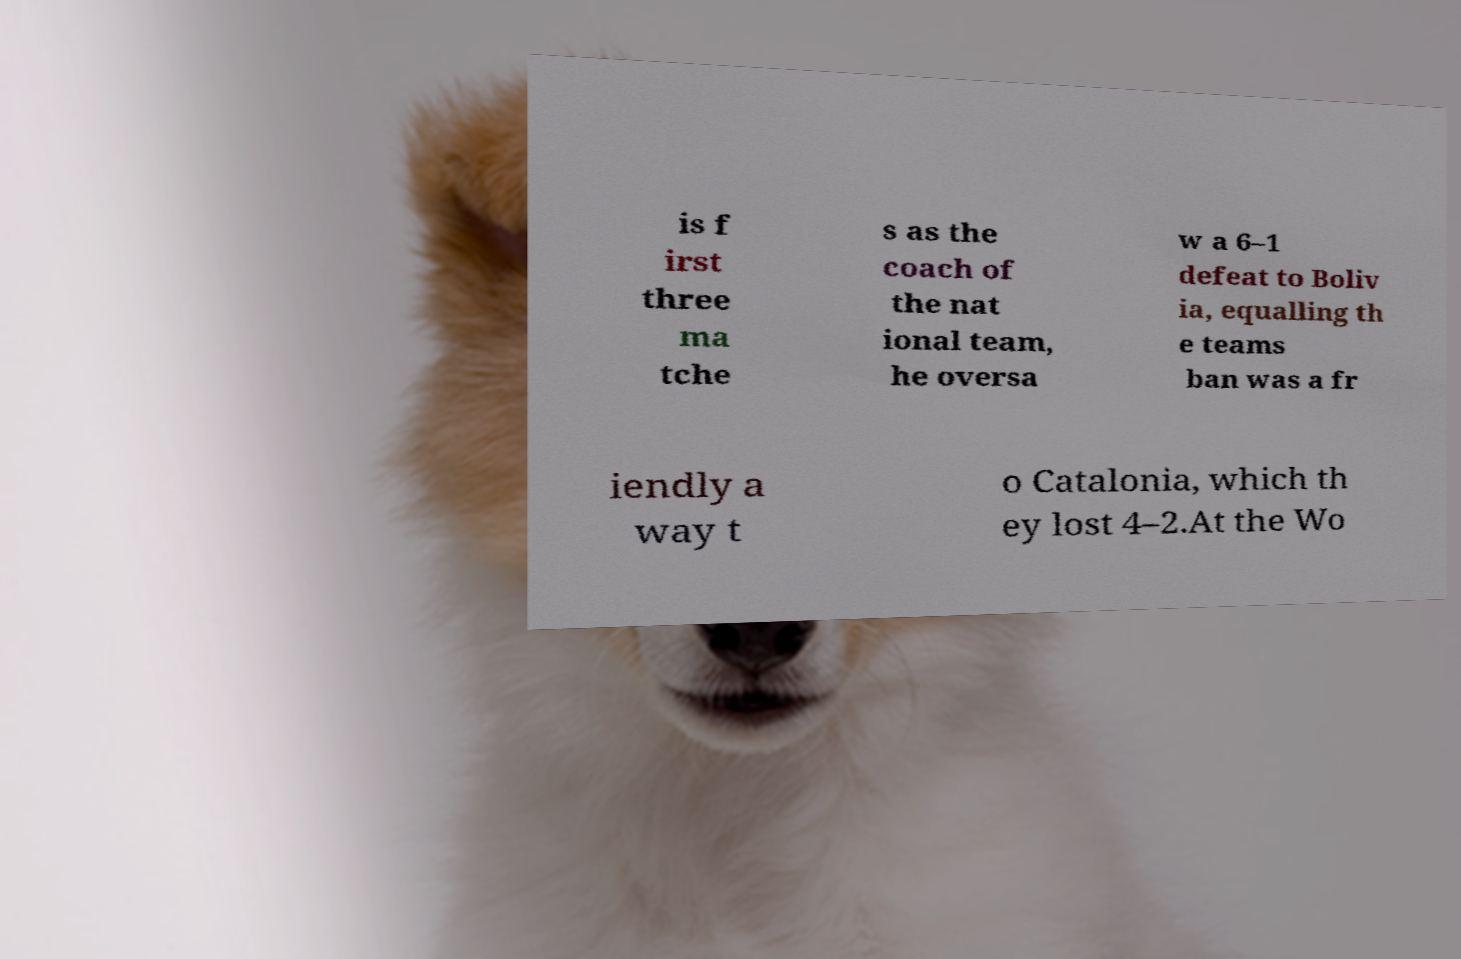I need the written content from this picture converted into text. Can you do that? is f irst three ma tche s as the coach of the nat ional team, he oversa w a 6–1 defeat to Boliv ia, equalling th e teams ban was a fr iendly a way t o Catalonia, which th ey lost 4–2.At the Wo 